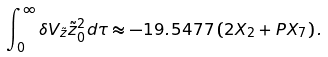Convert formula to latex. <formula><loc_0><loc_0><loc_500><loc_500>\int _ { 0 } ^ { \infty } \delta V _ { \tilde { z } } \tilde { z } _ { 0 } ^ { 2 } d \tau \approx - 1 9 . 5 4 7 7 \, ( 2 X _ { 2 } + P X _ { 7 } ) \, .</formula> 